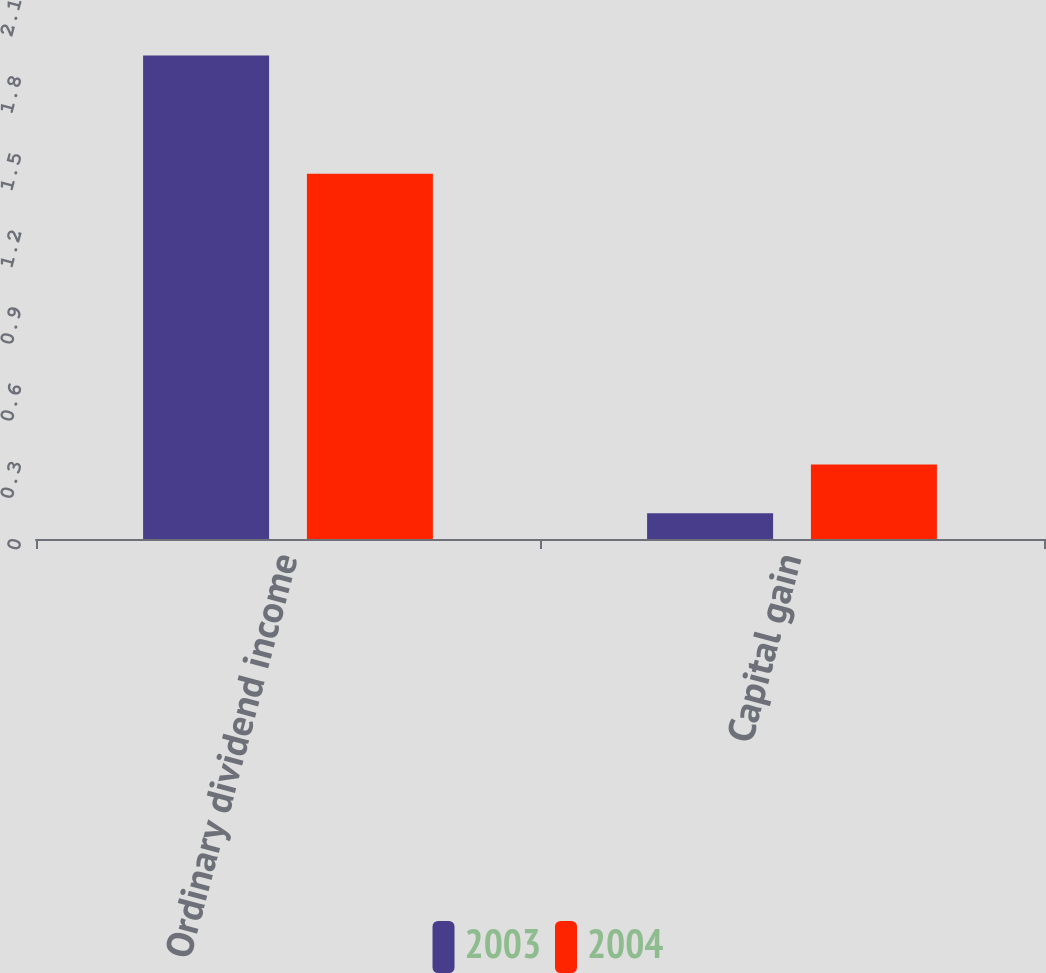Convert chart. <chart><loc_0><loc_0><loc_500><loc_500><stacked_bar_chart><ecel><fcel>Ordinary dividend income<fcel>Capital gain<nl><fcel>2003<fcel>1.88<fcel>0.1<nl><fcel>2004<fcel>1.42<fcel>0.29<nl></chart> 